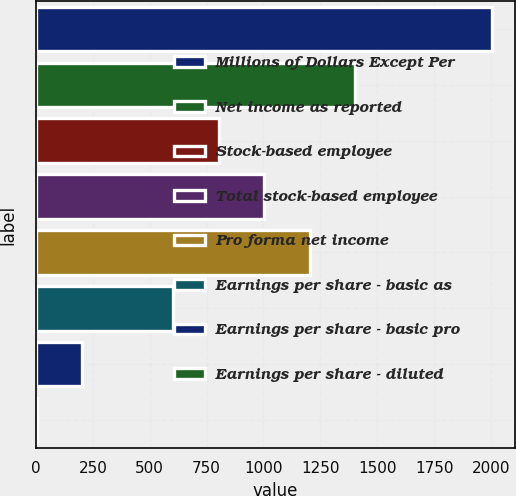Convert chart. <chart><loc_0><loc_0><loc_500><loc_500><bar_chart><fcel>Millions of Dollars Except Per<fcel>Net income as reported<fcel>Stock-based employee<fcel>Total stock-based employee<fcel>Pro forma net income<fcel>Earnings per share - basic as<fcel>Earnings per share - basic pro<fcel>Earnings per share - diluted<nl><fcel>2004<fcel>1403.48<fcel>802.94<fcel>1003.12<fcel>1203.3<fcel>602.76<fcel>202.4<fcel>2.22<nl></chart> 